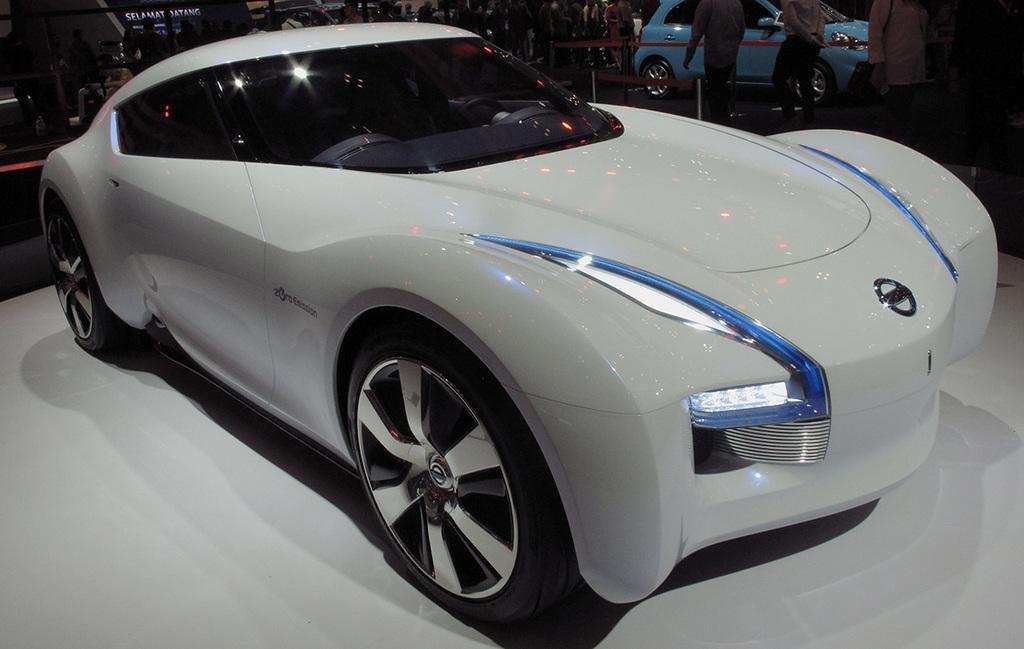Could you give a brief overview of what you see in this image? In this image we can see a group of people, some vehicles are parked on the ground, we can also see some poles and ribbons. At the top of the image we can see the sky. 